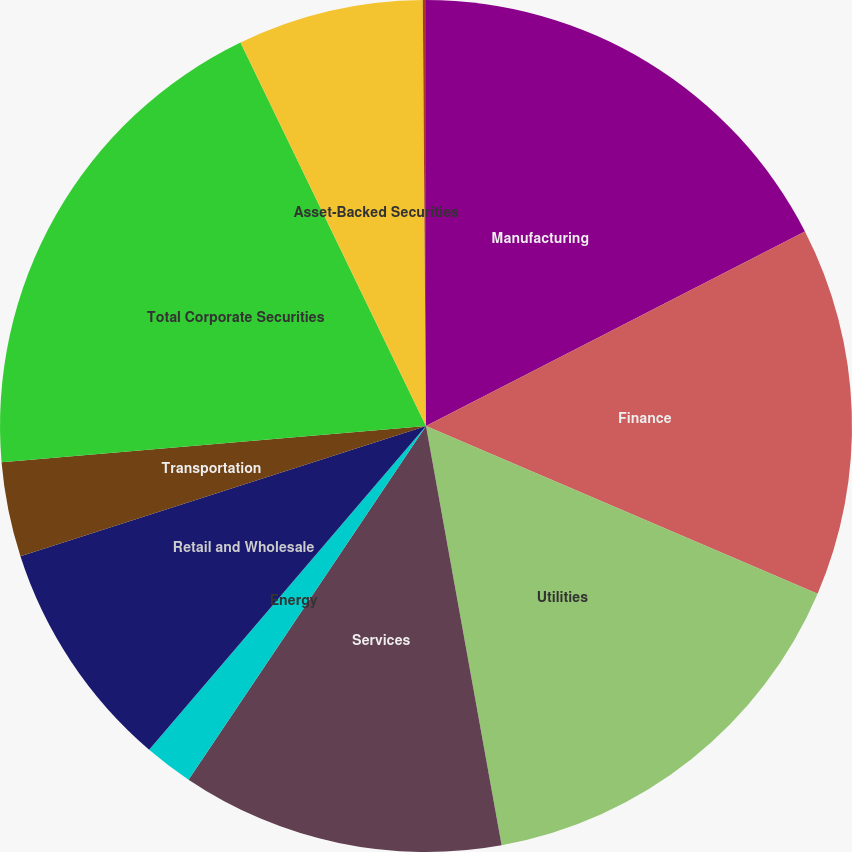Convert chart. <chart><loc_0><loc_0><loc_500><loc_500><pie_chart><fcel>Manufacturing<fcel>Finance<fcel>Utilities<fcel>Services<fcel>Energy<fcel>Retail and Wholesale<fcel>Transportation<fcel>Total Corporate Securities<fcel>Asset-Backed Securities<fcel>US Government<nl><fcel>17.45%<fcel>13.99%<fcel>15.72%<fcel>12.25%<fcel>1.85%<fcel>8.79%<fcel>3.59%<fcel>19.19%<fcel>7.05%<fcel>0.12%<nl></chart> 